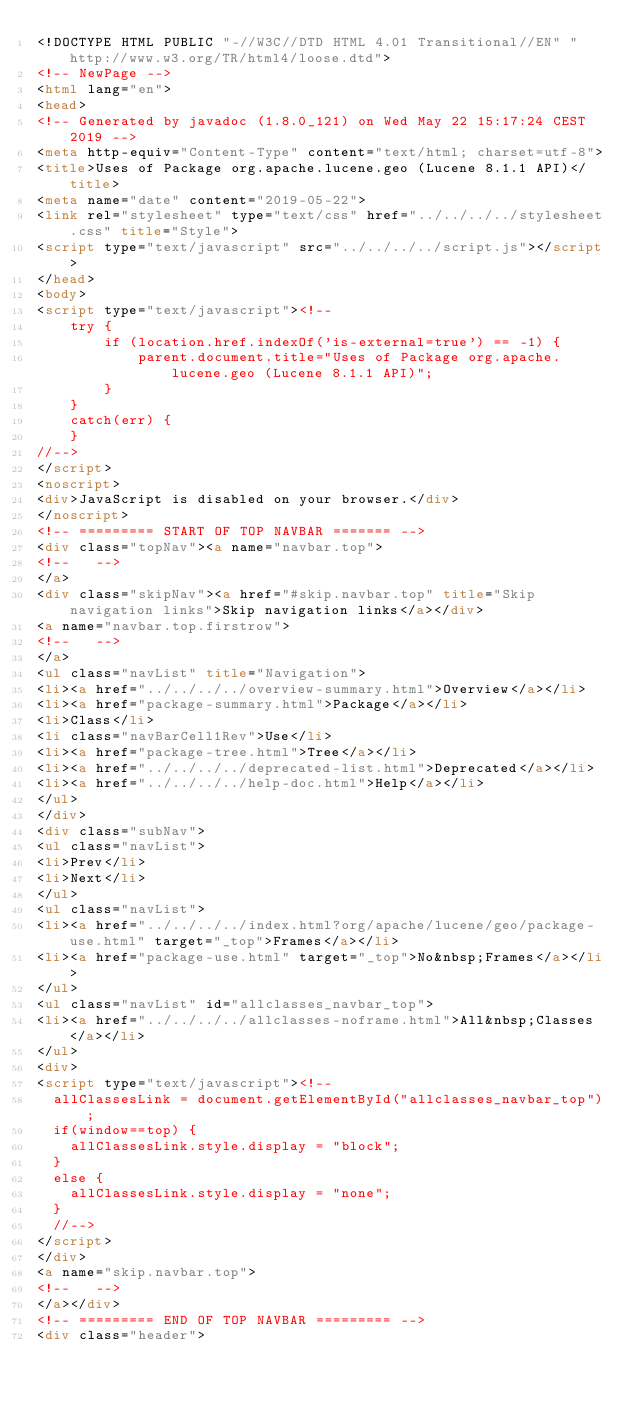<code> <loc_0><loc_0><loc_500><loc_500><_HTML_><!DOCTYPE HTML PUBLIC "-//W3C//DTD HTML 4.01 Transitional//EN" "http://www.w3.org/TR/html4/loose.dtd">
<!-- NewPage -->
<html lang="en">
<head>
<!-- Generated by javadoc (1.8.0_121) on Wed May 22 15:17:24 CEST 2019 -->
<meta http-equiv="Content-Type" content="text/html; charset=utf-8">
<title>Uses of Package org.apache.lucene.geo (Lucene 8.1.1 API)</title>
<meta name="date" content="2019-05-22">
<link rel="stylesheet" type="text/css" href="../../../../stylesheet.css" title="Style">
<script type="text/javascript" src="../../../../script.js"></script>
</head>
<body>
<script type="text/javascript"><!--
    try {
        if (location.href.indexOf('is-external=true') == -1) {
            parent.document.title="Uses of Package org.apache.lucene.geo (Lucene 8.1.1 API)";
        }
    }
    catch(err) {
    }
//-->
</script>
<noscript>
<div>JavaScript is disabled on your browser.</div>
</noscript>
<!-- ========= START OF TOP NAVBAR ======= -->
<div class="topNav"><a name="navbar.top">
<!--   -->
</a>
<div class="skipNav"><a href="#skip.navbar.top" title="Skip navigation links">Skip navigation links</a></div>
<a name="navbar.top.firstrow">
<!--   -->
</a>
<ul class="navList" title="Navigation">
<li><a href="../../../../overview-summary.html">Overview</a></li>
<li><a href="package-summary.html">Package</a></li>
<li>Class</li>
<li class="navBarCell1Rev">Use</li>
<li><a href="package-tree.html">Tree</a></li>
<li><a href="../../../../deprecated-list.html">Deprecated</a></li>
<li><a href="../../../../help-doc.html">Help</a></li>
</ul>
</div>
<div class="subNav">
<ul class="navList">
<li>Prev</li>
<li>Next</li>
</ul>
<ul class="navList">
<li><a href="../../../../index.html?org/apache/lucene/geo/package-use.html" target="_top">Frames</a></li>
<li><a href="package-use.html" target="_top">No&nbsp;Frames</a></li>
</ul>
<ul class="navList" id="allclasses_navbar_top">
<li><a href="../../../../allclasses-noframe.html">All&nbsp;Classes</a></li>
</ul>
<div>
<script type="text/javascript"><!--
  allClassesLink = document.getElementById("allclasses_navbar_top");
  if(window==top) {
    allClassesLink.style.display = "block";
  }
  else {
    allClassesLink.style.display = "none";
  }
  //-->
</script>
</div>
<a name="skip.navbar.top">
<!--   -->
</a></div>
<!-- ========= END OF TOP NAVBAR ========= -->
<div class="header"></code> 